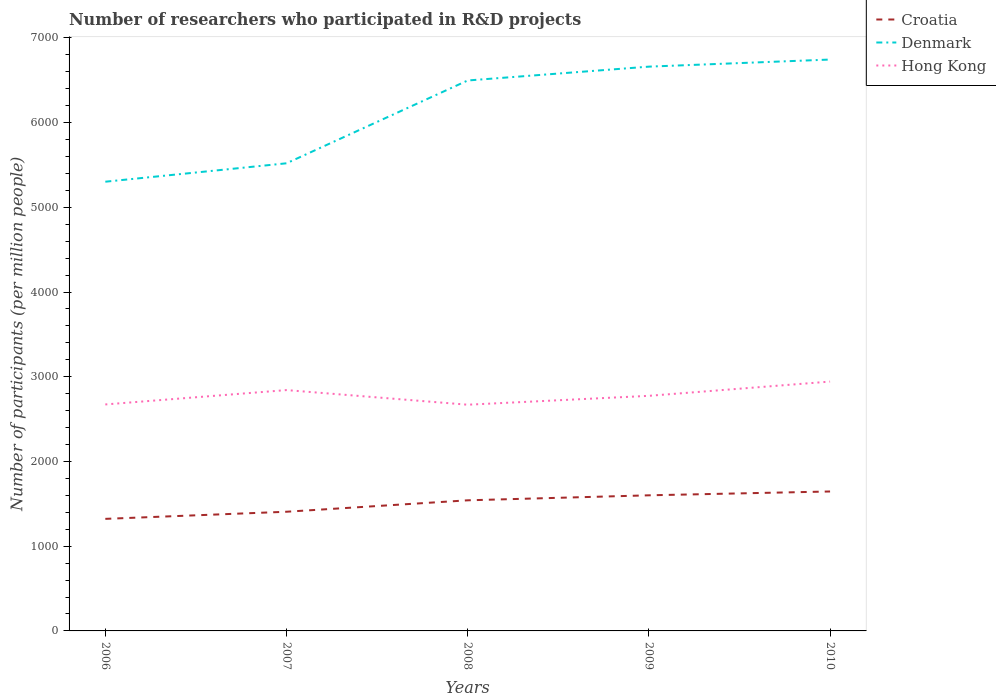Is the number of lines equal to the number of legend labels?
Ensure brevity in your answer.  Yes. Across all years, what is the maximum number of researchers who participated in R&D projects in Hong Kong?
Your answer should be very brief. 2669.9. What is the total number of researchers who participated in R&D projects in Hong Kong in the graph?
Ensure brevity in your answer.  -269.93. What is the difference between the highest and the second highest number of researchers who participated in R&D projects in Croatia?
Give a very brief answer. 323.16. What is the difference between the highest and the lowest number of researchers who participated in R&D projects in Croatia?
Ensure brevity in your answer.  3. How many years are there in the graph?
Your response must be concise. 5. How many legend labels are there?
Provide a succinct answer. 3. How are the legend labels stacked?
Provide a succinct answer. Vertical. What is the title of the graph?
Make the answer very short. Number of researchers who participated in R&D projects. Does "Ireland" appear as one of the legend labels in the graph?
Your response must be concise. No. What is the label or title of the Y-axis?
Provide a succinct answer. Number of participants (per million people). What is the Number of participants (per million people) of Croatia in 2006?
Offer a terse response. 1322.65. What is the Number of participants (per million people) of Denmark in 2006?
Provide a succinct answer. 5301.95. What is the Number of participants (per million people) of Hong Kong in 2006?
Your response must be concise. 2673.06. What is the Number of participants (per million people) in Croatia in 2007?
Your answer should be very brief. 1406.67. What is the Number of participants (per million people) of Denmark in 2007?
Make the answer very short. 5519.32. What is the Number of participants (per million people) in Hong Kong in 2007?
Offer a terse response. 2842.6. What is the Number of participants (per million people) of Croatia in 2008?
Keep it short and to the point. 1541.61. What is the Number of participants (per million people) of Denmark in 2008?
Your response must be concise. 6496.76. What is the Number of participants (per million people) of Hong Kong in 2008?
Your answer should be compact. 2669.9. What is the Number of participants (per million people) of Croatia in 2009?
Give a very brief answer. 1600.55. What is the Number of participants (per million people) of Denmark in 2009?
Make the answer very short. 6660.14. What is the Number of participants (per million people) of Hong Kong in 2009?
Offer a terse response. 2774.82. What is the Number of participants (per million people) in Croatia in 2010?
Ensure brevity in your answer.  1645.81. What is the Number of participants (per million people) of Denmark in 2010?
Ensure brevity in your answer.  6743.9. What is the Number of participants (per million people) of Hong Kong in 2010?
Ensure brevity in your answer.  2942.99. Across all years, what is the maximum Number of participants (per million people) of Croatia?
Ensure brevity in your answer.  1645.81. Across all years, what is the maximum Number of participants (per million people) of Denmark?
Make the answer very short. 6743.9. Across all years, what is the maximum Number of participants (per million people) in Hong Kong?
Offer a very short reply. 2942.99. Across all years, what is the minimum Number of participants (per million people) of Croatia?
Offer a very short reply. 1322.65. Across all years, what is the minimum Number of participants (per million people) in Denmark?
Offer a terse response. 5301.95. Across all years, what is the minimum Number of participants (per million people) in Hong Kong?
Offer a very short reply. 2669.9. What is the total Number of participants (per million people) in Croatia in the graph?
Offer a very short reply. 7517.28. What is the total Number of participants (per million people) of Denmark in the graph?
Provide a succinct answer. 3.07e+04. What is the total Number of participants (per million people) in Hong Kong in the graph?
Your response must be concise. 1.39e+04. What is the difference between the Number of participants (per million people) of Croatia in 2006 and that in 2007?
Provide a succinct answer. -84.02. What is the difference between the Number of participants (per million people) of Denmark in 2006 and that in 2007?
Offer a very short reply. -217.37. What is the difference between the Number of participants (per million people) in Hong Kong in 2006 and that in 2007?
Make the answer very short. -169.54. What is the difference between the Number of participants (per million people) of Croatia in 2006 and that in 2008?
Make the answer very short. -218.97. What is the difference between the Number of participants (per million people) of Denmark in 2006 and that in 2008?
Keep it short and to the point. -1194.82. What is the difference between the Number of participants (per million people) in Hong Kong in 2006 and that in 2008?
Offer a terse response. 3.16. What is the difference between the Number of participants (per million people) of Croatia in 2006 and that in 2009?
Your answer should be compact. -277.9. What is the difference between the Number of participants (per million people) in Denmark in 2006 and that in 2009?
Your answer should be very brief. -1358.2. What is the difference between the Number of participants (per million people) of Hong Kong in 2006 and that in 2009?
Your answer should be very brief. -101.76. What is the difference between the Number of participants (per million people) of Croatia in 2006 and that in 2010?
Offer a terse response. -323.16. What is the difference between the Number of participants (per million people) of Denmark in 2006 and that in 2010?
Provide a succinct answer. -1441.95. What is the difference between the Number of participants (per million people) of Hong Kong in 2006 and that in 2010?
Ensure brevity in your answer.  -269.93. What is the difference between the Number of participants (per million people) of Croatia in 2007 and that in 2008?
Keep it short and to the point. -134.95. What is the difference between the Number of participants (per million people) of Denmark in 2007 and that in 2008?
Offer a terse response. -977.45. What is the difference between the Number of participants (per million people) of Hong Kong in 2007 and that in 2008?
Ensure brevity in your answer.  172.7. What is the difference between the Number of participants (per million people) of Croatia in 2007 and that in 2009?
Provide a succinct answer. -193.88. What is the difference between the Number of participants (per million people) of Denmark in 2007 and that in 2009?
Provide a short and direct response. -1140.83. What is the difference between the Number of participants (per million people) in Hong Kong in 2007 and that in 2009?
Your answer should be very brief. 67.78. What is the difference between the Number of participants (per million people) in Croatia in 2007 and that in 2010?
Offer a terse response. -239.14. What is the difference between the Number of participants (per million people) in Denmark in 2007 and that in 2010?
Offer a terse response. -1224.58. What is the difference between the Number of participants (per million people) of Hong Kong in 2007 and that in 2010?
Give a very brief answer. -100.39. What is the difference between the Number of participants (per million people) in Croatia in 2008 and that in 2009?
Offer a very short reply. -58.93. What is the difference between the Number of participants (per million people) in Denmark in 2008 and that in 2009?
Ensure brevity in your answer.  -163.38. What is the difference between the Number of participants (per million people) of Hong Kong in 2008 and that in 2009?
Offer a terse response. -104.93. What is the difference between the Number of participants (per million people) in Croatia in 2008 and that in 2010?
Provide a short and direct response. -104.19. What is the difference between the Number of participants (per million people) of Denmark in 2008 and that in 2010?
Ensure brevity in your answer.  -247.13. What is the difference between the Number of participants (per million people) in Hong Kong in 2008 and that in 2010?
Ensure brevity in your answer.  -273.09. What is the difference between the Number of participants (per million people) of Croatia in 2009 and that in 2010?
Offer a very short reply. -45.26. What is the difference between the Number of participants (per million people) in Denmark in 2009 and that in 2010?
Provide a succinct answer. -83.75. What is the difference between the Number of participants (per million people) in Hong Kong in 2009 and that in 2010?
Keep it short and to the point. -168.17. What is the difference between the Number of participants (per million people) of Croatia in 2006 and the Number of participants (per million people) of Denmark in 2007?
Make the answer very short. -4196.67. What is the difference between the Number of participants (per million people) in Croatia in 2006 and the Number of participants (per million people) in Hong Kong in 2007?
Make the answer very short. -1519.95. What is the difference between the Number of participants (per million people) in Denmark in 2006 and the Number of participants (per million people) in Hong Kong in 2007?
Your answer should be very brief. 2459.35. What is the difference between the Number of participants (per million people) in Croatia in 2006 and the Number of participants (per million people) in Denmark in 2008?
Keep it short and to the point. -5174.12. What is the difference between the Number of participants (per million people) in Croatia in 2006 and the Number of participants (per million people) in Hong Kong in 2008?
Offer a very short reply. -1347.25. What is the difference between the Number of participants (per million people) in Denmark in 2006 and the Number of participants (per million people) in Hong Kong in 2008?
Make the answer very short. 2632.05. What is the difference between the Number of participants (per million people) in Croatia in 2006 and the Number of participants (per million people) in Denmark in 2009?
Give a very brief answer. -5337.5. What is the difference between the Number of participants (per million people) of Croatia in 2006 and the Number of participants (per million people) of Hong Kong in 2009?
Make the answer very short. -1452.18. What is the difference between the Number of participants (per million people) in Denmark in 2006 and the Number of participants (per million people) in Hong Kong in 2009?
Provide a short and direct response. 2527.12. What is the difference between the Number of participants (per million people) in Croatia in 2006 and the Number of participants (per million people) in Denmark in 2010?
Provide a short and direct response. -5421.25. What is the difference between the Number of participants (per million people) of Croatia in 2006 and the Number of participants (per million people) of Hong Kong in 2010?
Your answer should be very brief. -1620.34. What is the difference between the Number of participants (per million people) in Denmark in 2006 and the Number of participants (per million people) in Hong Kong in 2010?
Offer a very short reply. 2358.96. What is the difference between the Number of participants (per million people) in Croatia in 2007 and the Number of participants (per million people) in Denmark in 2008?
Provide a succinct answer. -5090.1. What is the difference between the Number of participants (per million people) of Croatia in 2007 and the Number of participants (per million people) of Hong Kong in 2008?
Your response must be concise. -1263.23. What is the difference between the Number of participants (per million people) of Denmark in 2007 and the Number of participants (per million people) of Hong Kong in 2008?
Your answer should be compact. 2849.42. What is the difference between the Number of participants (per million people) of Croatia in 2007 and the Number of participants (per million people) of Denmark in 2009?
Keep it short and to the point. -5253.48. What is the difference between the Number of participants (per million people) in Croatia in 2007 and the Number of participants (per million people) in Hong Kong in 2009?
Your answer should be very brief. -1368.16. What is the difference between the Number of participants (per million people) in Denmark in 2007 and the Number of participants (per million people) in Hong Kong in 2009?
Provide a succinct answer. 2744.49. What is the difference between the Number of participants (per million people) of Croatia in 2007 and the Number of participants (per million people) of Denmark in 2010?
Provide a short and direct response. -5337.23. What is the difference between the Number of participants (per million people) of Croatia in 2007 and the Number of participants (per million people) of Hong Kong in 2010?
Ensure brevity in your answer.  -1536.32. What is the difference between the Number of participants (per million people) of Denmark in 2007 and the Number of participants (per million people) of Hong Kong in 2010?
Your response must be concise. 2576.33. What is the difference between the Number of participants (per million people) in Croatia in 2008 and the Number of participants (per million people) in Denmark in 2009?
Ensure brevity in your answer.  -5118.53. What is the difference between the Number of participants (per million people) in Croatia in 2008 and the Number of participants (per million people) in Hong Kong in 2009?
Provide a succinct answer. -1233.21. What is the difference between the Number of participants (per million people) of Denmark in 2008 and the Number of participants (per million people) of Hong Kong in 2009?
Offer a terse response. 3721.94. What is the difference between the Number of participants (per million people) of Croatia in 2008 and the Number of participants (per million people) of Denmark in 2010?
Provide a short and direct response. -5202.28. What is the difference between the Number of participants (per million people) of Croatia in 2008 and the Number of participants (per million people) of Hong Kong in 2010?
Offer a terse response. -1401.38. What is the difference between the Number of participants (per million people) in Denmark in 2008 and the Number of participants (per million people) in Hong Kong in 2010?
Provide a succinct answer. 3553.77. What is the difference between the Number of participants (per million people) of Croatia in 2009 and the Number of participants (per million people) of Denmark in 2010?
Ensure brevity in your answer.  -5143.35. What is the difference between the Number of participants (per million people) of Croatia in 2009 and the Number of participants (per million people) of Hong Kong in 2010?
Your answer should be compact. -1342.44. What is the difference between the Number of participants (per million people) of Denmark in 2009 and the Number of participants (per million people) of Hong Kong in 2010?
Your answer should be compact. 3717.15. What is the average Number of participants (per million people) in Croatia per year?
Ensure brevity in your answer.  1503.46. What is the average Number of participants (per million people) in Denmark per year?
Your answer should be very brief. 6144.41. What is the average Number of participants (per million people) in Hong Kong per year?
Your response must be concise. 2780.67. In the year 2006, what is the difference between the Number of participants (per million people) in Croatia and Number of participants (per million people) in Denmark?
Offer a terse response. -3979.3. In the year 2006, what is the difference between the Number of participants (per million people) in Croatia and Number of participants (per million people) in Hong Kong?
Keep it short and to the point. -1350.41. In the year 2006, what is the difference between the Number of participants (per million people) of Denmark and Number of participants (per million people) of Hong Kong?
Provide a succinct answer. 2628.89. In the year 2007, what is the difference between the Number of participants (per million people) in Croatia and Number of participants (per million people) in Denmark?
Give a very brief answer. -4112.65. In the year 2007, what is the difference between the Number of participants (per million people) of Croatia and Number of participants (per million people) of Hong Kong?
Provide a succinct answer. -1435.93. In the year 2007, what is the difference between the Number of participants (per million people) in Denmark and Number of participants (per million people) in Hong Kong?
Make the answer very short. 2676.72. In the year 2008, what is the difference between the Number of participants (per million people) in Croatia and Number of participants (per million people) in Denmark?
Your response must be concise. -4955.15. In the year 2008, what is the difference between the Number of participants (per million people) in Croatia and Number of participants (per million people) in Hong Kong?
Ensure brevity in your answer.  -1128.28. In the year 2008, what is the difference between the Number of participants (per million people) of Denmark and Number of participants (per million people) of Hong Kong?
Offer a terse response. 3826.87. In the year 2009, what is the difference between the Number of participants (per million people) of Croatia and Number of participants (per million people) of Denmark?
Your answer should be compact. -5059.6. In the year 2009, what is the difference between the Number of participants (per million people) of Croatia and Number of participants (per million people) of Hong Kong?
Ensure brevity in your answer.  -1174.28. In the year 2009, what is the difference between the Number of participants (per million people) of Denmark and Number of participants (per million people) of Hong Kong?
Your answer should be very brief. 3885.32. In the year 2010, what is the difference between the Number of participants (per million people) in Croatia and Number of participants (per million people) in Denmark?
Your answer should be compact. -5098.09. In the year 2010, what is the difference between the Number of participants (per million people) in Croatia and Number of participants (per million people) in Hong Kong?
Your response must be concise. -1297.18. In the year 2010, what is the difference between the Number of participants (per million people) in Denmark and Number of participants (per million people) in Hong Kong?
Your answer should be compact. 3800.91. What is the ratio of the Number of participants (per million people) of Croatia in 2006 to that in 2007?
Make the answer very short. 0.94. What is the ratio of the Number of participants (per million people) in Denmark in 2006 to that in 2007?
Your answer should be compact. 0.96. What is the ratio of the Number of participants (per million people) of Hong Kong in 2006 to that in 2007?
Make the answer very short. 0.94. What is the ratio of the Number of participants (per million people) in Croatia in 2006 to that in 2008?
Make the answer very short. 0.86. What is the ratio of the Number of participants (per million people) in Denmark in 2006 to that in 2008?
Your answer should be compact. 0.82. What is the ratio of the Number of participants (per million people) of Croatia in 2006 to that in 2009?
Give a very brief answer. 0.83. What is the ratio of the Number of participants (per million people) of Denmark in 2006 to that in 2009?
Ensure brevity in your answer.  0.8. What is the ratio of the Number of participants (per million people) in Hong Kong in 2006 to that in 2009?
Keep it short and to the point. 0.96. What is the ratio of the Number of participants (per million people) of Croatia in 2006 to that in 2010?
Ensure brevity in your answer.  0.8. What is the ratio of the Number of participants (per million people) in Denmark in 2006 to that in 2010?
Provide a succinct answer. 0.79. What is the ratio of the Number of participants (per million people) of Hong Kong in 2006 to that in 2010?
Offer a very short reply. 0.91. What is the ratio of the Number of participants (per million people) in Croatia in 2007 to that in 2008?
Provide a short and direct response. 0.91. What is the ratio of the Number of participants (per million people) of Denmark in 2007 to that in 2008?
Make the answer very short. 0.85. What is the ratio of the Number of participants (per million people) of Hong Kong in 2007 to that in 2008?
Your answer should be compact. 1.06. What is the ratio of the Number of participants (per million people) in Croatia in 2007 to that in 2009?
Offer a terse response. 0.88. What is the ratio of the Number of participants (per million people) in Denmark in 2007 to that in 2009?
Your answer should be compact. 0.83. What is the ratio of the Number of participants (per million people) in Hong Kong in 2007 to that in 2009?
Your answer should be very brief. 1.02. What is the ratio of the Number of participants (per million people) in Croatia in 2007 to that in 2010?
Your answer should be very brief. 0.85. What is the ratio of the Number of participants (per million people) of Denmark in 2007 to that in 2010?
Provide a short and direct response. 0.82. What is the ratio of the Number of participants (per million people) of Hong Kong in 2007 to that in 2010?
Offer a terse response. 0.97. What is the ratio of the Number of participants (per million people) of Croatia in 2008 to that in 2009?
Ensure brevity in your answer.  0.96. What is the ratio of the Number of participants (per million people) in Denmark in 2008 to that in 2009?
Keep it short and to the point. 0.98. What is the ratio of the Number of participants (per million people) in Hong Kong in 2008 to that in 2009?
Ensure brevity in your answer.  0.96. What is the ratio of the Number of participants (per million people) in Croatia in 2008 to that in 2010?
Make the answer very short. 0.94. What is the ratio of the Number of participants (per million people) in Denmark in 2008 to that in 2010?
Your response must be concise. 0.96. What is the ratio of the Number of participants (per million people) of Hong Kong in 2008 to that in 2010?
Keep it short and to the point. 0.91. What is the ratio of the Number of participants (per million people) of Croatia in 2009 to that in 2010?
Offer a terse response. 0.97. What is the ratio of the Number of participants (per million people) of Denmark in 2009 to that in 2010?
Give a very brief answer. 0.99. What is the ratio of the Number of participants (per million people) in Hong Kong in 2009 to that in 2010?
Your answer should be very brief. 0.94. What is the difference between the highest and the second highest Number of participants (per million people) in Croatia?
Offer a terse response. 45.26. What is the difference between the highest and the second highest Number of participants (per million people) in Denmark?
Your response must be concise. 83.75. What is the difference between the highest and the second highest Number of participants (per million people) of Hong Kong?
Your answer should be compact. 100.39. What is the difference between the highest and the lowest Number of participants (per million people) in Croatia?
Provide a short and direct response. 323.16. What is the difference between the highest and the lowest Number of participants (per million people) of Denmark?
Keep it short and to the point. 1441.95. What is the difference between the highest and the lowest Number of participants (per million people) of Hong Kong?
Offer a terse response. 273.09. 